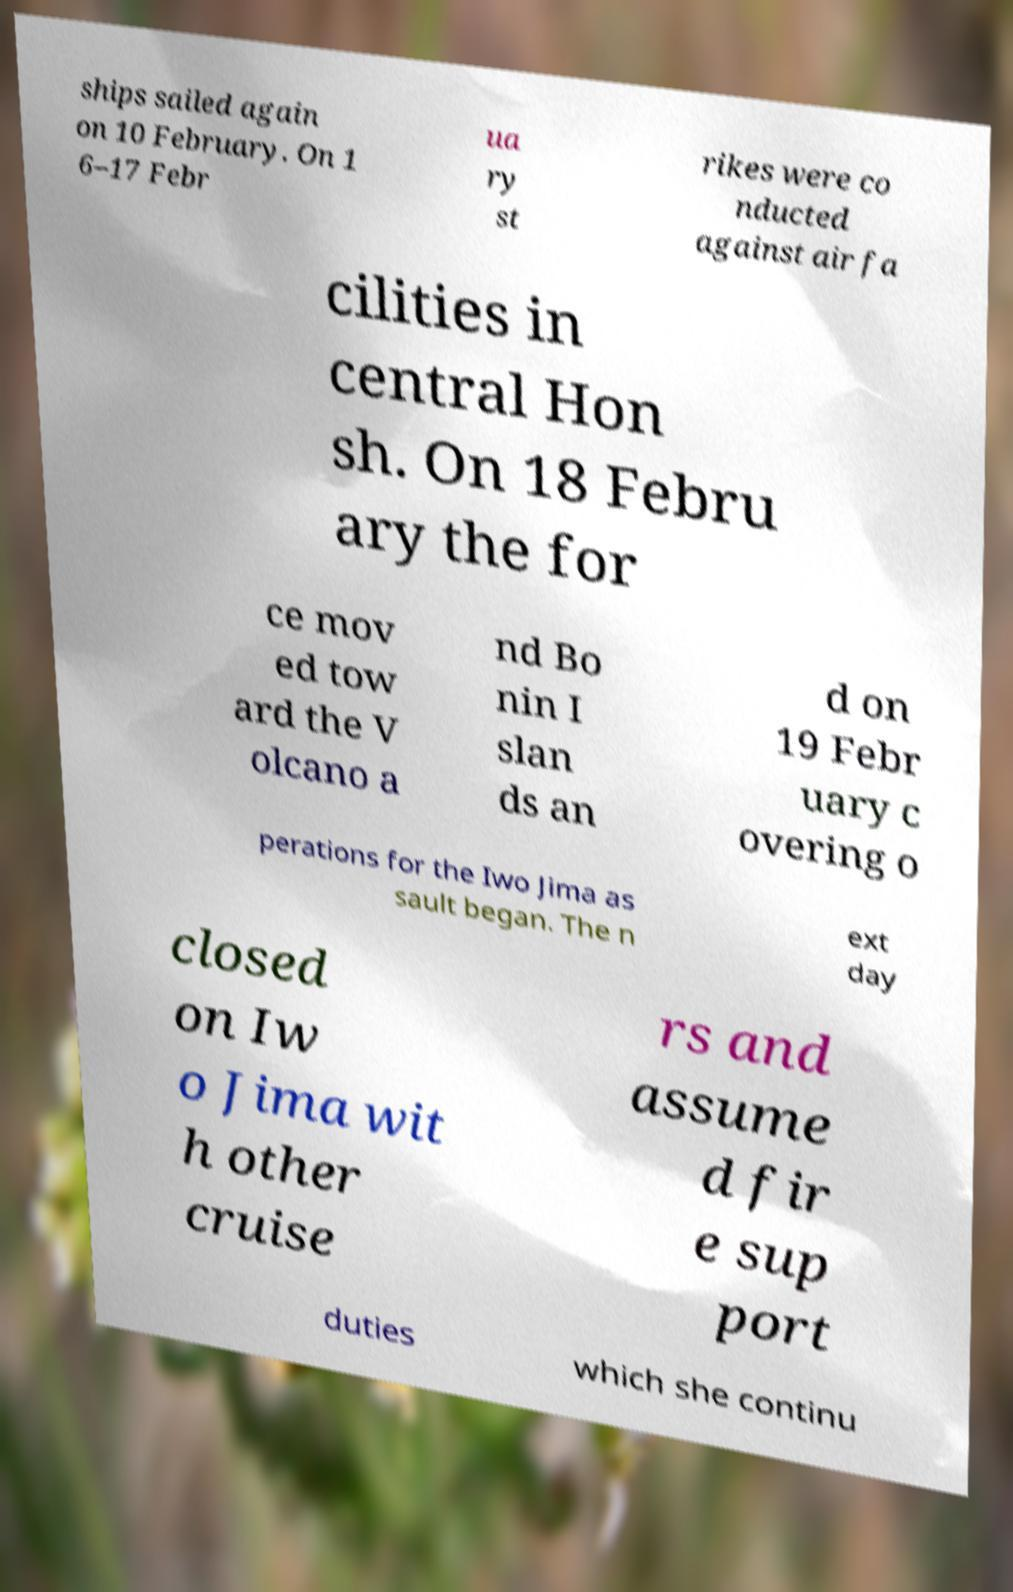What messages or text are displayed in this image? I need them in a readable, typed format. ships sailed again on 10 February. On 1 6–17 Febr ua ry st rikes were co nducted against air fa cilities in central Hon sh. On 18 Febru ary the for ce mov ed tow ard the V olcano a nd Bo nin I slan ds an d on 19 Febr uary c overing o perations for the Iwo Jima as sault began. The n ext day closed on Iw o Jima wit h other cruise rs and assume d fir e sup port duties which she continu 